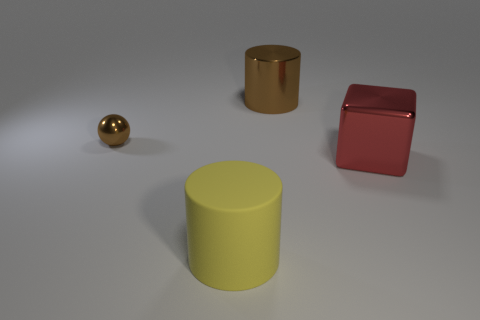Add 3 large brown cylinders. How many objects exist? 7 Subtract all spheres. How many objects are left? 3 Add 3 big metallic blocks. How many big metallic blocks are left? 4 Add 1 tiny gray balls. How many tiny gray balls exist? 1 Subtract 0 cyan cylinders. How many objects are left? 4 Subtract all metallic cubes. Subtract all small balls. How many objects are left? 2 